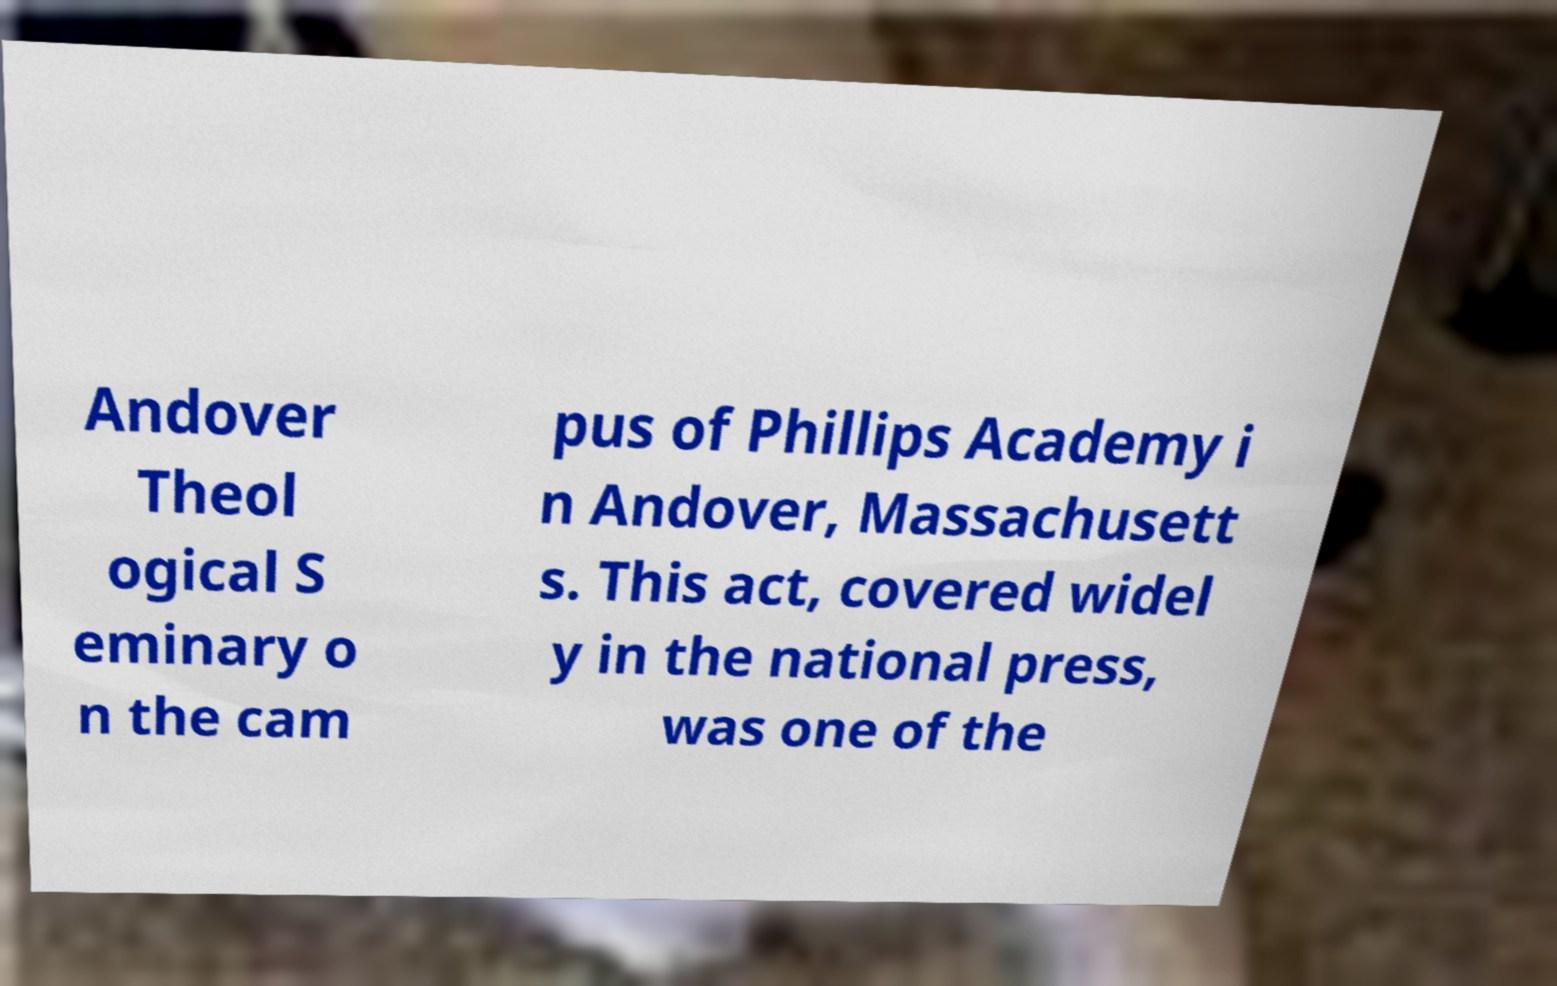Can you read and provide the text displayed in the image?This photo seems to have some interesting text. Can you extract and type it out for me? Andover Theol ogical S eminary o n the cam pus of Phillips Academy i n Andover, Massachusett s. This act, covered widel y in the national press, was one of the 